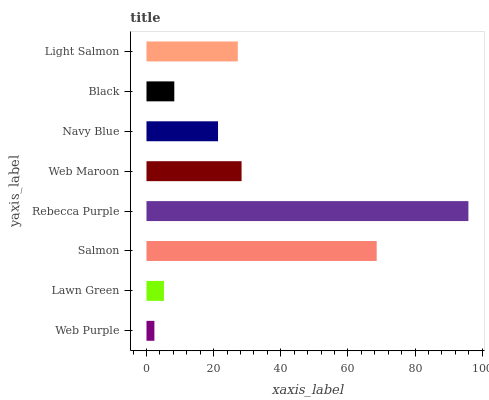Is Web Purple the minimum?
Answer yes or no. Yes. Is Rebecca Purple the maximum?
Answer yes or no. Yes. Is Lawn Green the minimum?
Answer yes or no. No. Is Lawn Green the maximum?
Answer yes or no. No. Is Lawn Green greater than Web Purple?
Answer yes or no. Yes. Is Web Purple less than Lawn Green?
Answer yes or no. Yes. Is Web Purple greater than Lawn Green?
Answer yes or no. No. Is Lawn Green less than Web Purple?
Answer yes or no. No. Is Light Salmon the high median?
Answer yes or no. Yes. Is Navy Blue the low median?
Answer yes or no. Yes. Is Rebecca Purple the high median?
Answer yes or no. No. Is Rebecca Purple the low median?
Answer yes or no. No. 